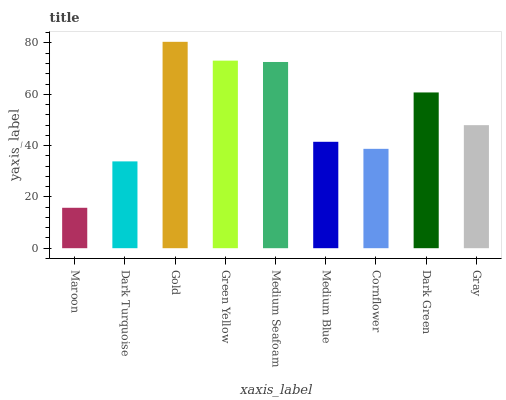Is Maroon the minimum?
Answer yes or no. Yes. Is Gold the maximum?
Answer yes or no. Yes. Is Dark Turquoise the minimum?
Answer yes or no. No. Is Dark Turquoise the maximum?
Answer yes or no. No. Is Dark Turquoise greater than Maroon?
Answer yes or no. Yes. Is Maroon less than Dark Turquoise?
Answer yes or no. Yes. Is Maroon greater than Dark Turquoise?
Answer yes or no. No. Is Dark Turquoise less than Maroon?
Answer yes or no. No. Is Gray the high median?
Answer yes or no. Yes. Is Gray the low median?
Answer yes or no. Yes. Is Dark Turquoise the high median?
Answer yes or no. No. Is Green Yellow the low median?
Answer yes or no. No. 